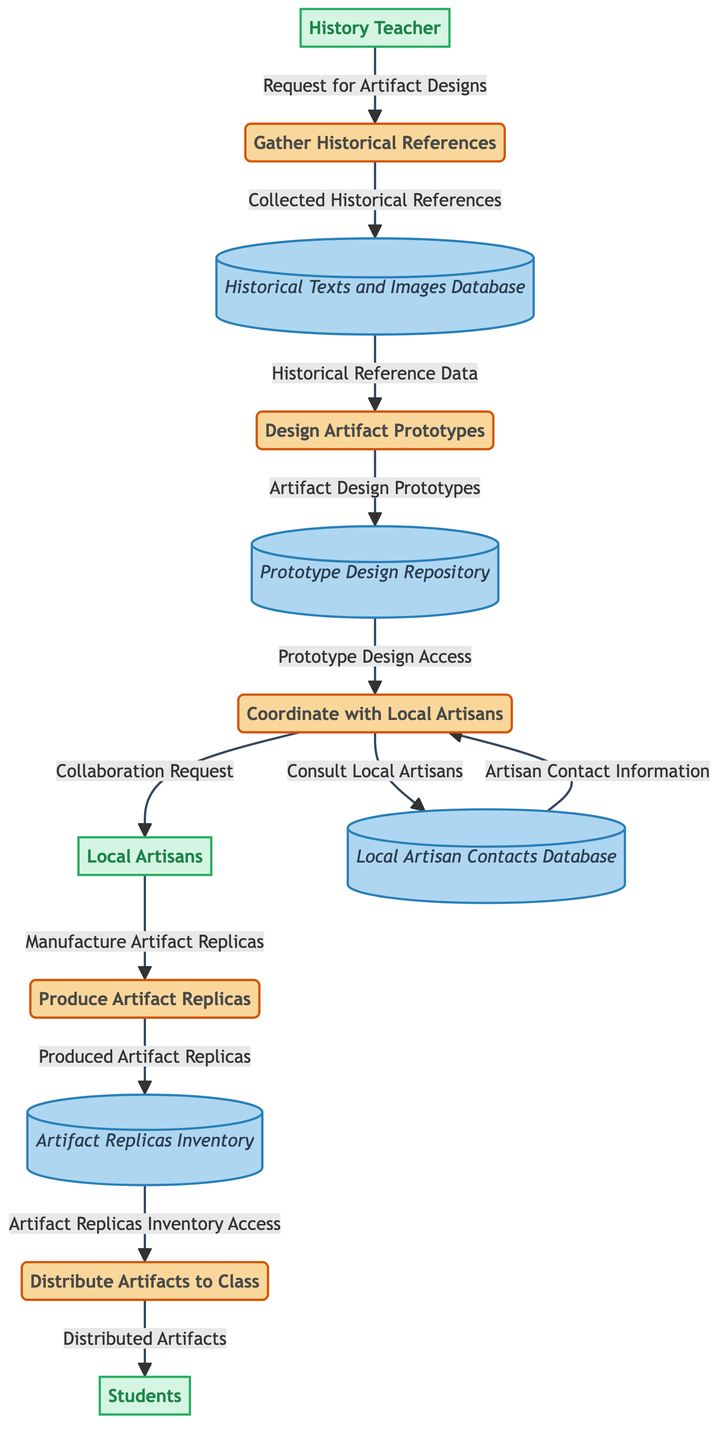What is the first process in the diagram? The first process in the diagram is indicated as the one connected to the History Teacher with the label "Gather Historical References".
Answer: Gather Historical References How many data flows are there in total? By counting the arrows connecting the nodes, there are a total of 12 distinct data flows depicted in the diagram.
Answer: 12 Which database stores the "Prototype Design Access"? The "Prototype Design Access" is associated with the Prototype Design Repository, as indicated by the arrow flowing from the repository to the process Design Artifact Prototypes.
Answer: Prototype Design Repository Who initiates the request for artifact designs? The request for artifact designs originates from the History Teacher, as shown by the arrow going from the entity labeled History Teacher to the process labeled Gather Historical References.
Answer: History Teacher How many external entities are present in the diagram? The diagram includes three external entities: History Teacher, Students, and Local Artisans, which can be counted visually.
Answer: 3 What is the last process in the flow? The last process in the flow, which distributes the artifacts, is labeled "Distribute Artifacts to Class".
Answer: Distribute Artifacts to Class Which artifact is produced in the fourth process? The fourth process, labeled "Produce Artifact Replicas", indicates that artifact replicas are manufactured as part of this stage.
Answer: Artifact Replicas What information is needed to design artifact prototypes? The process "Design Artifact Prototypes" requires "Historical Reference Data" as its input, which is provided by the "Historical Texts and Images Database".
Answer: Historical Reference Data Which external entity receives the distributed artifacts? The distributed artifacts are given to the Students as indicated by the final flow from the process "Distribute Artifacts to Class" to the entity labeled Students.
Answer: Students 